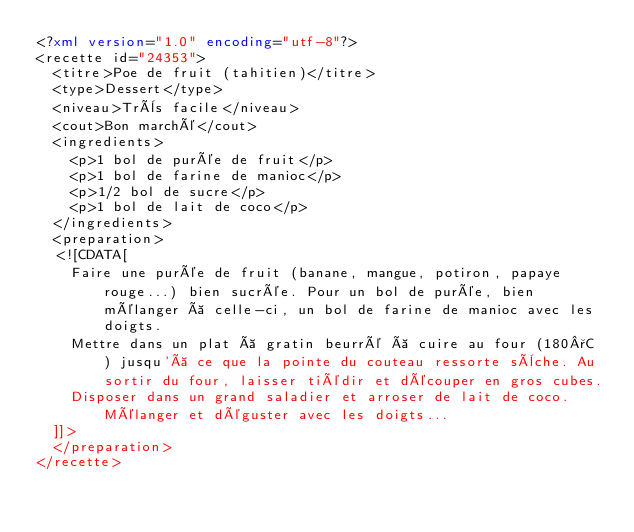<code> <loc_0><loc_0><loc_500><loc_500><_XML_><?xml version="1.0" encoding="utf-8"?>
<recette id="24353">
  <titre>Poe de fruit (tahitien)</titre>
  <type>Dessert</type>
  <niveau>Très facile</niveau>
  <cout>Bon marché</cout>
  <ingredients>
    <p>1 bol de purée de fruit</p>
    <p>1 bol de farine de manioc</p>
    <p>1/2 bol de sucre</p>
    <p>1 bol de lait de coco</p>
  </ingredients>
  <preparation>
  <![CDATA[
    Faire une purée de fruit (banane, mangue, potiron, papaye rouge...) bien sucrée. Pour un bol de purée, bien mélanger à celle-ci, un bol de farine de manioc avec les doigts. 
    Mettre dans un plat à gratin beurré à cuire au four (180°C ) jusqu'à ce que la pointe du couteau ressorte sèche. Au sortir du four, laisser tiédir et découper en gros cubes. 
    Disposer dans un grand saladier et arroser de lait de coco. Mélanger et déguster avec les doigts...
  ]]>
  </preparation>
</recette>
</code> 